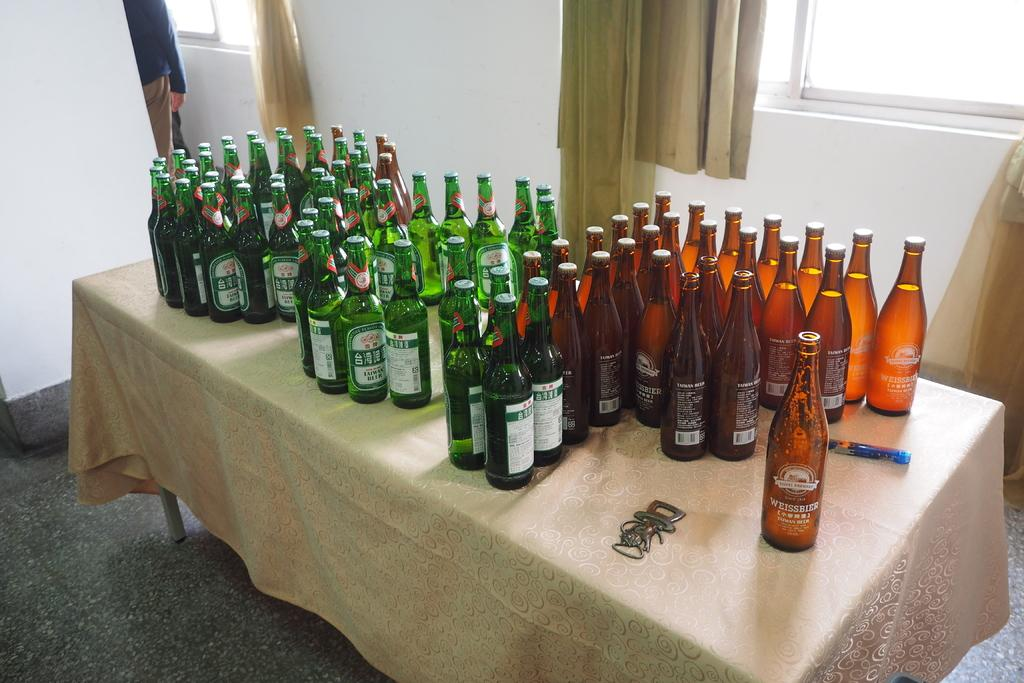<image>
Provide a brief description of the given image. Three options of beer, one being  weissbier, sit on a table table with a tablecloth on it 